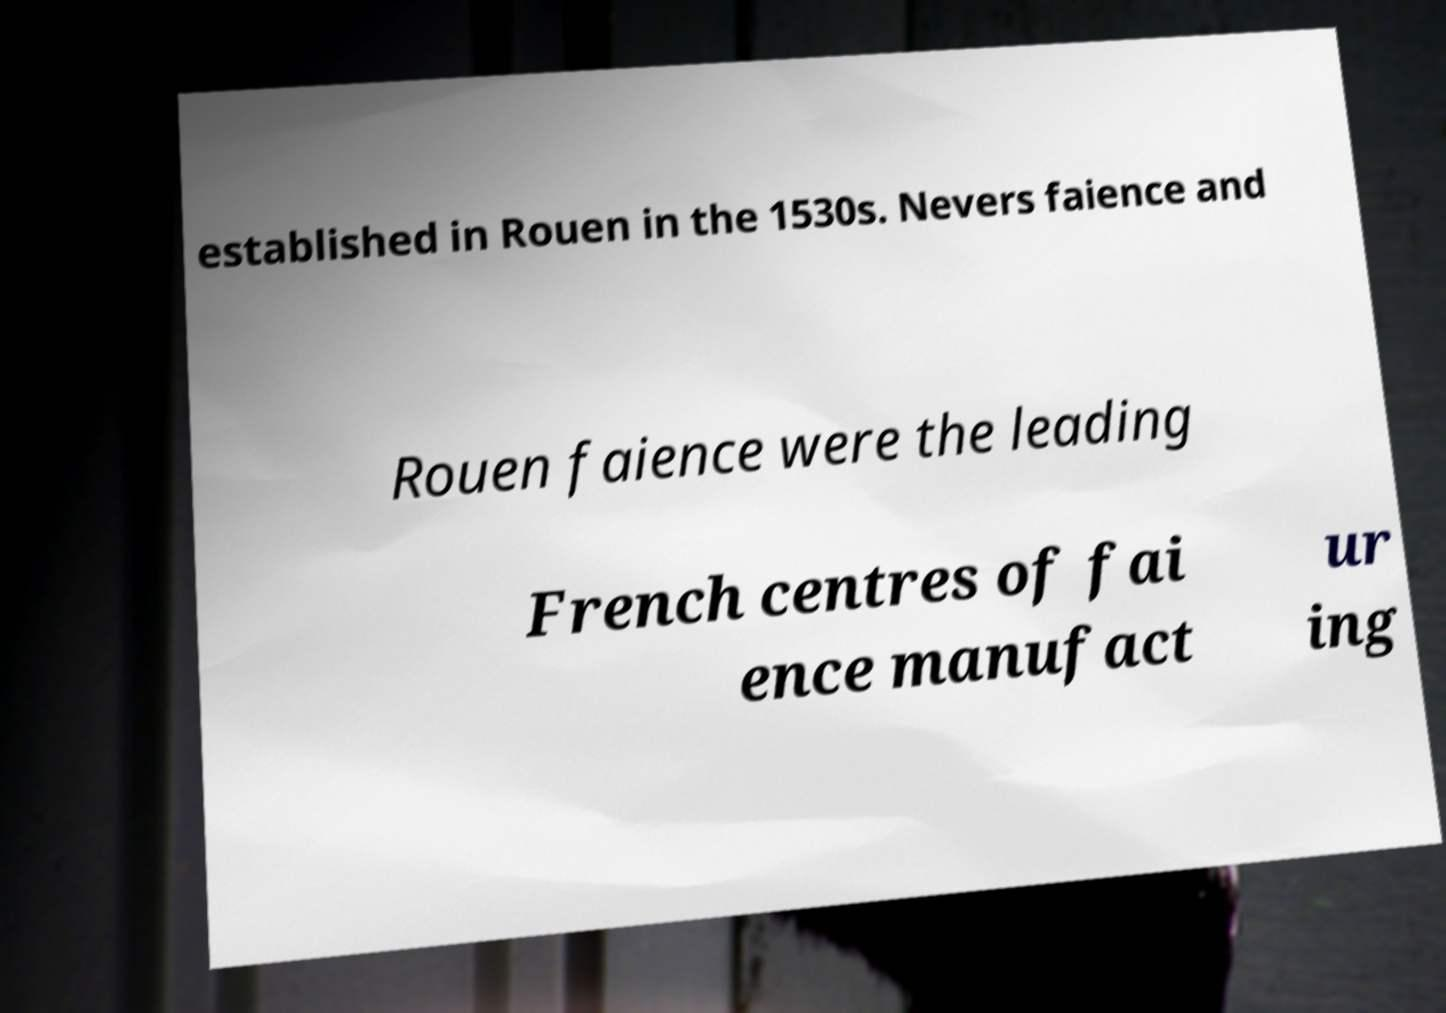There's text embedded in this image that I need extracted. Can you transcribe it verbatim? established in Rouen in the 1530s. Nevers faience and Rouen faience were the leading French centres of fai ence manufact ur ing 